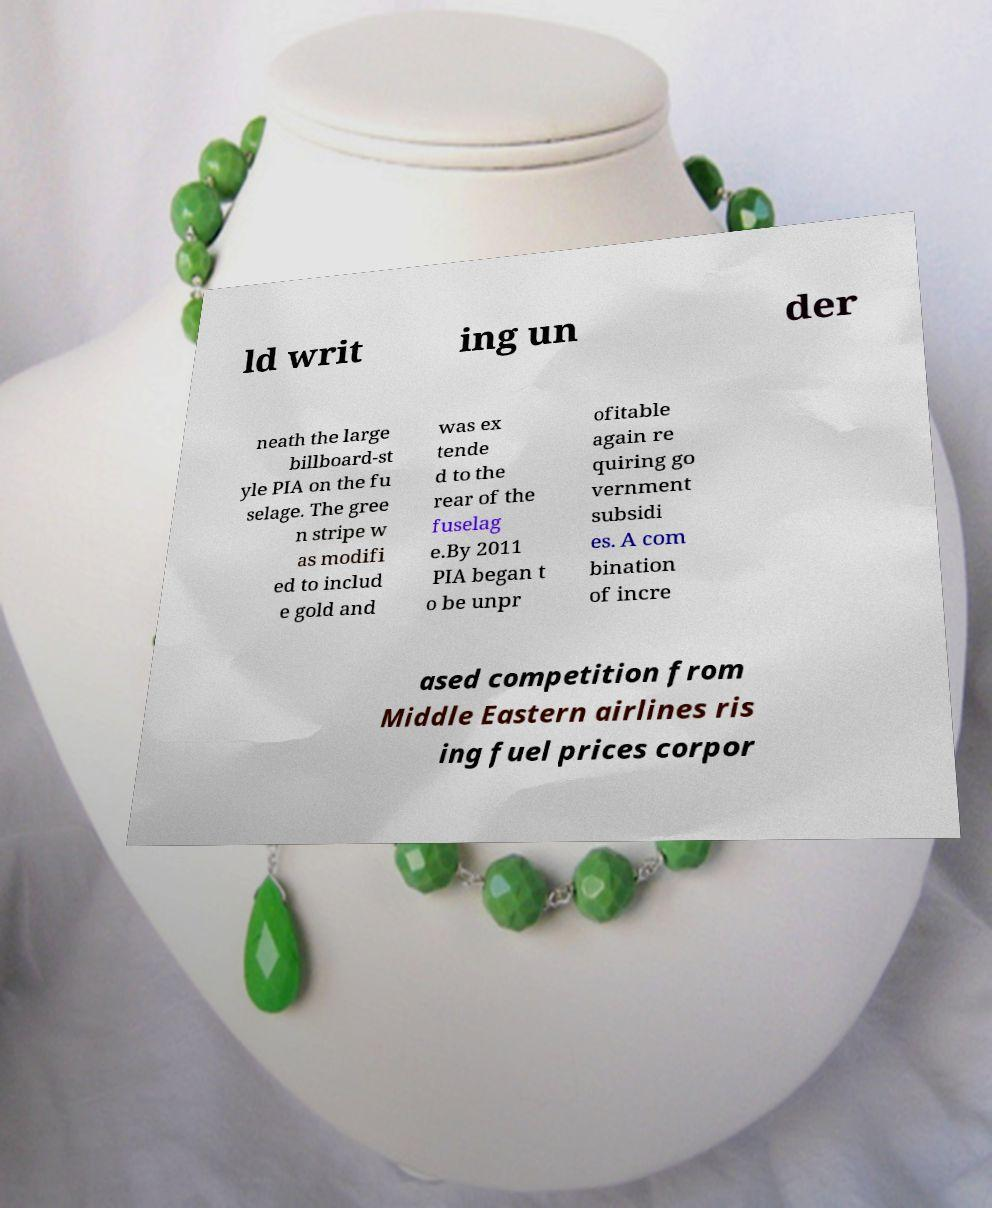Please identify and transcribe the text found in this image. ld writ ing un der neath the large billboard-st yle PIA on the fu selage. The gree n stripe w as modifi ed to includ e gold and was ex tende d to the rear of the fuselag e.By 2011 PIA began t o be unpr ofitable again re quiring go vernment subsidi es. A com bination of incre ased competition from Middle Eastern airlines ris ing fuel prices corpor 